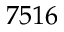<formula> <loc_0><loc_0><loc_500><loc_500>7 5 1 6</formula> 